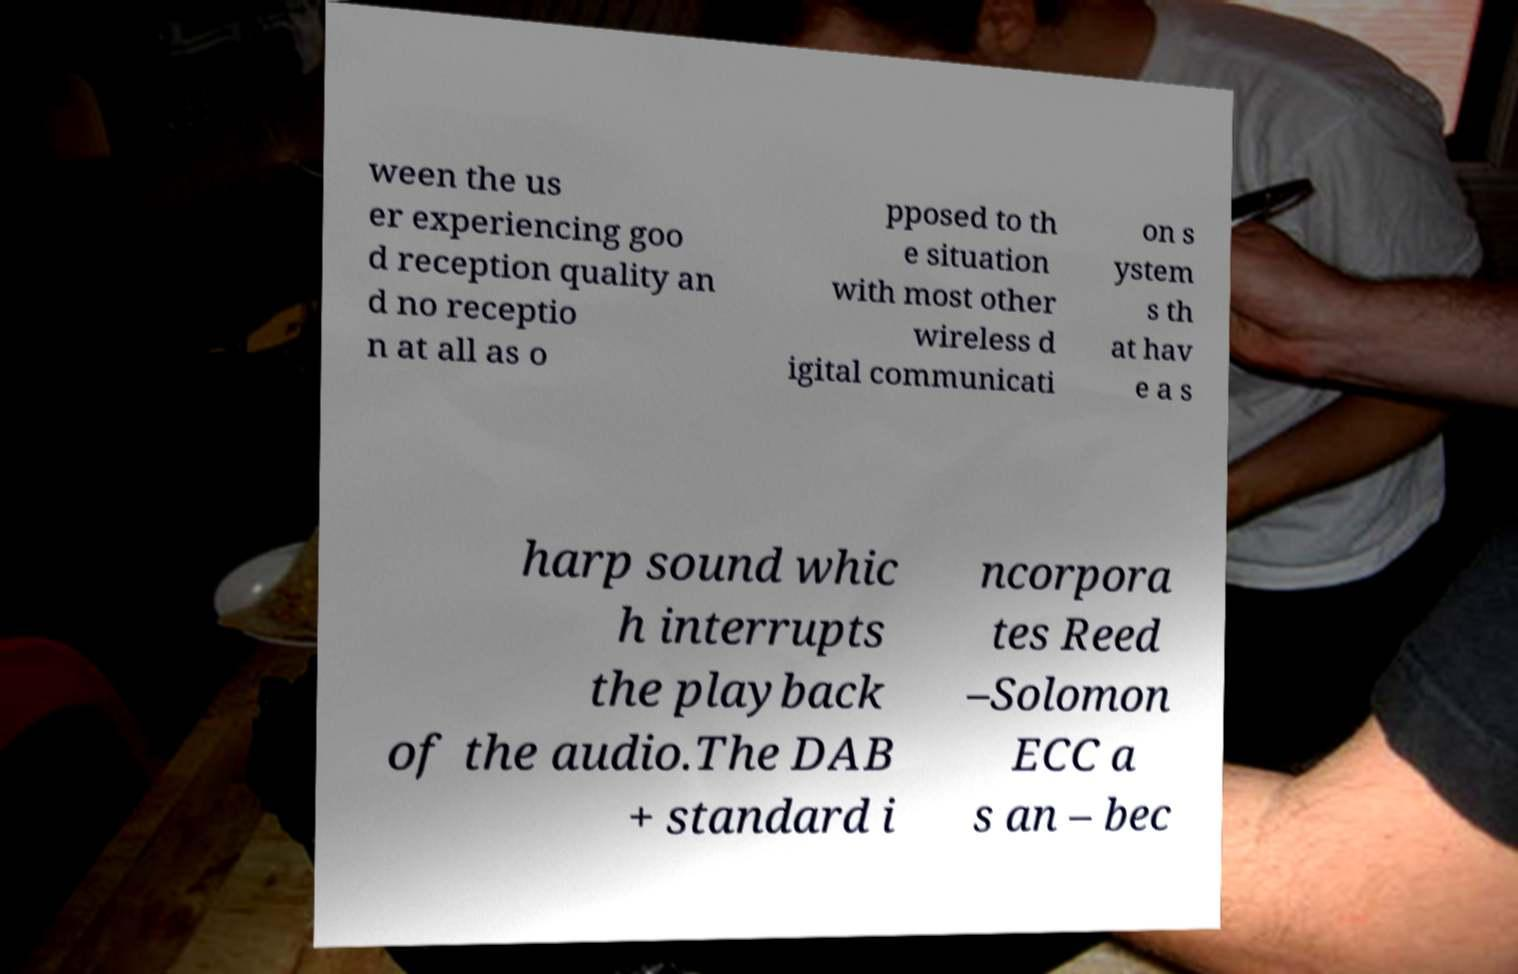Please read and relay the text visible in this image. What does it say? ween the us er experiencing goo d reception quality an d no receptio n at all as o pposed to th e situation with most other wireless d igital communicati on s ystem s th at hav e a s harp sound whic h interrupts the playback of the audio.The DAB + standard i ncorpora tes Reed –Solomon ECC a s an – bec 